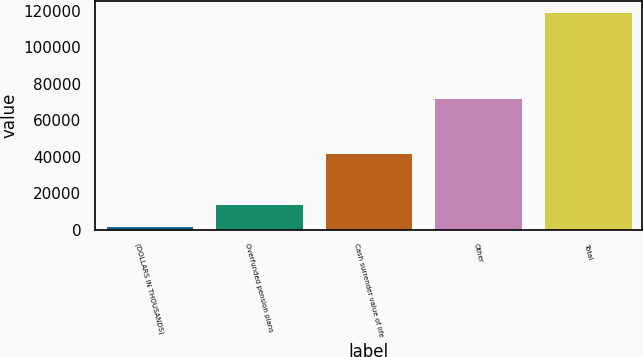Convert chart to OTSL. <chart><loc_0><loc_0><loc_500><loc_500><bar_chart><fcel>(DOLLARS IN THOUSANDS)<fcel>Overfunded pension plans<fcel>Cash surrender value of life<fcel>Other<fcel>Total<nl><fcel>2015<fcel>13719.5<fcel>41957<fcel>72197<fcel>119060<nl></chart> 